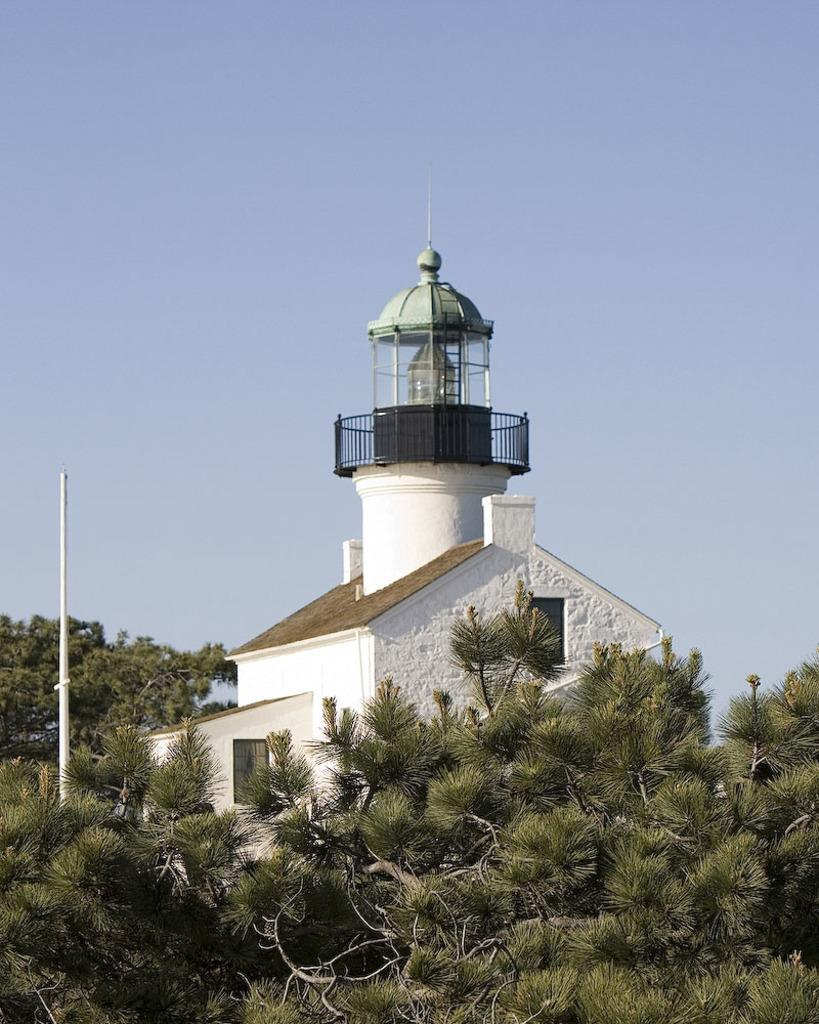What type of structure is visible in the image? There is a building in the image. What is the condition of the sky in the image? The sky is clear in the image. What type of vegetation can be seen in the image? There are trees in the image. What type of plastic object is being used to rake the scene in the image? There is no plastic object or raking activity present in the image. 